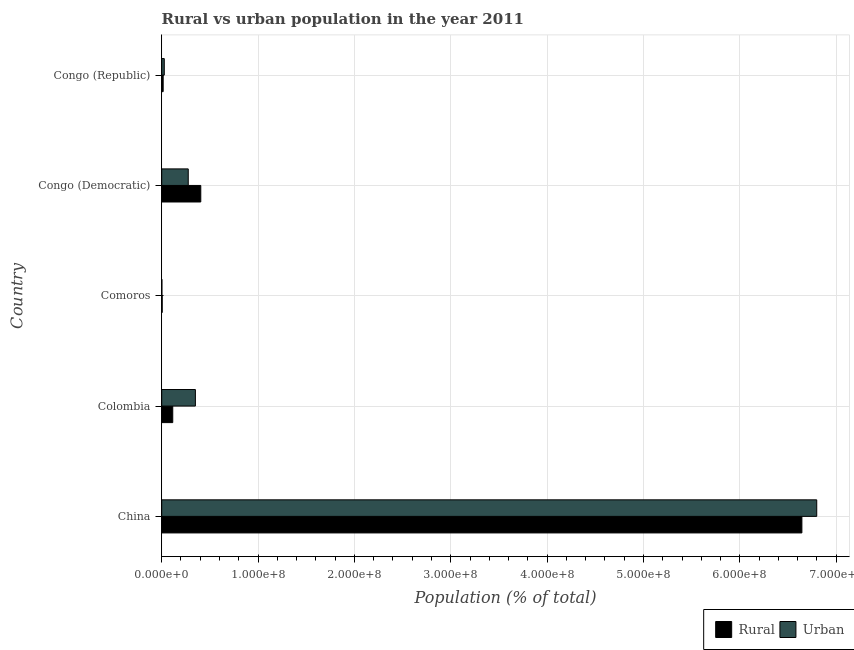How many groups of bars are there?
Keep it short and to the point. 5. Are the number of bars per tick equal to the number of legend labels?
Provide a succinct answer. Yes. What is the label of the 3rd group of bars from the top?
Provide a short and direct response. Comoros. What is the urban population density in Congo (Republic)?
Make the answer very short. 2.66e+06. Across all countries, what is the maximum urban population density?
Offer a terse response. 6.80e+08. Across all countries, what is the minimum rural population density?
Offer a terse response. 5.16e+05. In which country was the urban population density minimum?
Your response must be concise. Comoros. What is the total rural population density in the graph?
Make the answer very short. 7.18e+08. What is the difference between the urban population density in Colombia and that in Congo (Democratic)?
Ensure brevity in your answer.  7.42e+06. What is the difference between the urban population density in Colombia and the rural population density in Congo (Republic)?
Ensure brevity in your answer.  3.34e+07. What is the average urban population density per country?
Keep it short and to the point. 1.49e+08. What is the difference between the rural population density and urban population density in Congo (Republic)?
Ensure brevity in your answer.  -1.14e+06. In how many countries, is the urban population density greater than 220000000 %?
Give a very brief answer. 1. What is the ratio of the rural population density in China to that in Colombia?
Offer a very short reply. 58.01. Is the urban population density in Colombia less than that in Congo (Democratic)?
Offer a terse response. No. Is the difference between the urban population density in China and Congo (Democratic) greater than the difference between the rural population density in China and Congo (Democratic)?
Your response must be concise. Yes. What is the difference between the highest and the second highest urban population density?
Ensure brevity in your answer.  6.45e+08. What is the difference between the highest and the lowest rural population density?
Make the answer very short. 6.64e+08. In how many countries, is the rural population density greater than the average rural population density taken over all countries?
Your response must be concise. 1. What does the 2nd bar from the top in China represents?
Your answer should be very brief. Rural. What does the 1st bar from the bottom in Comoros represents?
Offer a very short reply. Rural. Are all the bars in the graph horizontal?
Your response must be concise. Yes. What is the difference between two consecutive major ticks on the X-axis?
Your answer should be very brief. 1.00e+08. Does the graph contain any zero values?
Your answer should be compact. No. Where does the legend appear in the graph?
Your answer should be very brief. Bottom right. What is the title of the graph?
Your answer should be compact. Rural vs urban population in the year 2011. Does "Diesel" appear as one of the legend labels in the graph?
Offer a very short reply. No. What is the label or title of the X-axis?
Offer a very short reply. Population (% of total). What is the Population (% of total) in Rural in China?
Make the answer very short. 6.64e+08. What is the Population (% of total) in Urban in China?
Your answer should be compact. 6.80e+08. What is the Population (% of total) of Rural in Colombia?
Make the answer very short. 1.15e+07. What is the Population (% of total) in Urban in Colombia?
Your response must be concise. 3.50e+07. What is the Population (% of total) of Rural in Comoros?
Provide a short and direct response. 5.16e+05. What is the Population (% of total) of Urban in Comoros?
Provide a succinct answer. 2.00e+05. What is the Population (% of total) in Rural in Congo (Democratic)?
Keep it short and to the point. 4.06e+07. What is the Population (% of total) in Urban in Congo (Democratic)?
Offer a very short reply. 2.75e+07. What is the Population (% of total) of Rural in Congo (Republic)?
Your response must be concise. 1.52e+06. What is the Population (% of total) in Urban in Congo (Republic)?
Your answer should be very brief. 2.66e+06. Across all countries, what is the maximum Population (% of total) of Rural?
Your response must be concise. 6.64e+08. Across all countries, what is the maximum Population (% of total) of Urban?
Your answer should be compact. 6.80e+08. Across all countries, what is the minimum Population (% of total) of Rural?
Keep it short and to the point. 5.16e+05. Across all countries, what is the minimum Population (% of total) in Urban?
Offer a terse response. 2.00e+05. What is the total Population (% of total) in Rural in the graph?
Make the answer very short. 7.18e+08. What is the total Population (% of total) of Urban in the graph?
Ensure brevity in your answer.  7.45e+08. What is the difference between the Population (% of total) in Rural in China and that in Colombia?
Your answer should be compact. 6.53e+08. What is the difference between the Population (% of total) in Urban in China and that in Colombia?
Ensure brevity in your answer.  6.45e+08. What is the difference between the Population (% of total) of Rural in China and that in Comoros?
Provide a short and direct response. 6.64e+08. What is the difference between the Population (% of total) of Urban in China and that in Comoros?
Offer a very short reply. 6.80e+08. What is the difference between the Population (% of total) of Rural in China and that in Congo (Democratic)?
Your answer should be very brief. 6.24e+08. What is the difference between the Population (% of total) in Urban in China and that in Congo (Democratic)?
Your answer should be compact. 6.52e+08. What is the difference between the Population (% of total) in Rural in China and that in Congo (Republic)?
Provide a short and direct response. 6.63e+08. What is the difference between the Population (% of total) of Urban in China and that in Congo (Republic)?
Offer a very short reply. 6.77e+08. What is the difference between the Population (% of total) in Rural in Colombia and that in Comoros?
Provide a succinct answer. 1.09e+07. What is the difference between the Population (% of total) in Urban in Colombia and that in Comoros?
Offer a terse response. 3.48e+07. What is the difference between the Population (% of total) of Rural in Colombia and that in Congo (Democratic)?
Provide a short and direct response. -2.91e+07. What is the difference between the Population (% of total) in Urban in Colombia and that in Congo (Democratic)?
Provide a succinct answer. 7.42e+06. What is the difference between the Population (% of total) of Rural in Colombia and that in Congo (Republic)?
Your answer should be compact. 9.93e+06. What is the difference between the Population (% of total) of Urban in Colombia and that in Congo (Republic)?
Provide a succinct answer. 3.23e+07. What is the difference between the Population (% of total) of Rural in Comoros and that in Congo (Democratic)?
Keep it short and to the point. -4.00e+07. What is the difference between the Population (% of total) in Urban in Comoros and that in Congo (Democratic)?
Provide a succinct answer. -2.73e+07. What is the difference between the Population (% of total) in Rural in Comoros and that in Congo (Republic)?
Give a very brief answer. -1.00e+06. What is the difference between the Population (% of total) of Urban in Comoros and that in Congo (Republic)?
Give a very brief answer. -2.46e+06. What is the difference between the Population (% of total) of Rural in Congo (Democratic) and that in Congo (Republic)?
Provide a succinct answer. 3.90e+07. What is the difference between the Population (% of total) in Urban in Congo (Democratic) and that in Congo (Republic)?
Give a very brief answer. 2.49e+07. What is the difference between the Population (% of total) in Rural in China and the Population (% of total) in Urban in Colombia?
Offer a very short reply. 6.29e+08. What is the difference between the Population (% of total) of Rural in China and the Population (% of total) of Urban in Comoros?
Offer a terse response. 6.64e+08. What is the difference between the Population (% of total) of Rural in China and the Population (% of total) of Urban in Congo (Democratic)?
Keep it short and to the point. 6.37e+08. What is the difference between the Population (% of total) in Rural in China and the Population (% of total) in Urban in Congo (Republic)?
Ensure brevity in your answer.  6.62e+08. What is the difference between the Population (% of total) of Rural in Colombia and the Population (% of total) of Urban in Comoros?
Your answer should be very brief. 1.13e+07. What is the difference between the Population (% of total) of Rural in Colombia and the Population (% of total) of Urban in Congo (Democratic)?
Your response must be concise. -1.61e+07. What is the difference between the Population (% of total) of Rural in Colombia and the Population (% of total) of Urban in Congo (Republic)?
Make the answer very short. 8.79e+06. What is the difference between the Population (% of total) in Rural in Comoros and the Population (% of total) in Urban in Congo (Democratic)?
Offer a very short reply. -2.70e+07. What is the difference between the Population (% of total) of Rural in Comoros and the Population (% of total) of Urban in Congo (Republic)?
Make the answer very short. -2.14e+06. What is the difference between the Population (% of total) in Rural in Congo (Democratic) and the Population (% of total) in Urban in Congo (Republic)?
Offer a very short reply. 3.79e+07. What is the average Population (% of total) in Rural per country?
Ensure brevity in your answer.  1.44e+08. What is the average Population (% of total) in Urban per country?
Offer a terse response. 1.49e+08. What is the difference between the Population (% of total) of Rural and Population (% of total) of Urban in China?
Make the answer very short. -1.54e+07. What is the difference between the Population (% of total) in Rural and Population (% of total) in Urban in Colombia?
Your answer should be very brief. -2.35e+07. What is the difference between the Population (% of total) of Rural and Population (% of total) of Urban in Comoros?
Keep it short and to the point. 3.16e+05. What is the difference between the Population (% of total) of Rural and Population (% of total) of Urban in Congo (Democratic)?
Provide a short and direct response. 1.30e+07. What is the difference between the Population (% of total) of Rural and Population (% of total) of Urban in Congo (Republic)?
Keep it short and to the point. -1.14e+06. What is the ratio of the Population (% of total) of Rural in China to that in Colombia?
Make the answer very short. 58.01. What is the ratio of the Population (% of total) in Urban in China to that in Colombia?
Provide a succinct answer. 19.45. What is the ratio of the Population (% of total) in Rural in China to that in Comoros?
Provide a succinct answer. 1288.17. What is the ratio of the Population (% of total) in Urban in China to that in Comoros?
Give a very brief answer. 3394.95. What is the ratio of the Population (% of total) of Rural in China to that in Congo (Democratic)?
Your answer should be very brief. 16.38. What is the ratio of the Population (% of total) of Urban in China to that in Congo (Democratic)?
Give a very brief answer. 24.69. What is the ratio of the Population (% of total) of Rural in China to that in Congo (Republic)?
Keep it short and to the point. 437.71. What is the ratio of the Population (% of total) in Urban in China to that in Congo (Republic)?
Your response must be concise. 255.59. What is the ratio of the Population (% of total) in Rural in Colombia to that in Comoros?
Make the answer very short. 22.21. What is the ratio of the Population (% of total) in Urban in Colombia to that in Comoros?
Offer a very short reply. 174.57. What is the ratio of the Population (% of total) of Rural in Colombia to that in Congo (Democratic)?
Keep it short and to the point. 0.28. What is the ratio of the Population (% of total) in Urban in Colombia to that in Congo (Democratic)?
Provide a succinct answer. 1.27. What is the ratio of the Population (% of total) of Rural in Colombia to that in Congo (Republic)?
Provide a short and direct response. 7.55. What is the ratio of the Population (% of total) in Urban in Colombia to that in Congo (Republic)?
Keep it short and to the point. 13.14. What is the ratio of the Population (% of total) of Rural in Comoros to that in Congo (Democratic)?
Provide a succinct answer. 0.01. What is the ratio of the Population (% of total) in Urban in Comoros to that in Congo (Democratic)?
Make the answer very short. 0.01. What is the ratio of the Population (% of total) in Rural in Comoros to that in Congo (Republic)?
Your answer should be compact. 0.34. What is the ratio of the Population (% of total) of Urban in Comoros to that in Congo (Republic)?
Offer a very short reply. 0.08. What is the ratio of the Population (% of total) of Rural in Congo (Democratic) to that in Congo (Republic)?
Your answer should be very brief. 26.72. What is the ratio of the Population (% of total) in Urban in Congo (Democratic) to that in Congo (Republic)?
Your answer should be compact. 10.35. What is the difference between the highest and the second highest Population (% of total) in Rural?
Make the answer very short. 6.24e+08. What is the difference between the highest and the second highest Population (% of total) of Urban?
Keep it short and to the point. 6.45e+08. What is the difference between the highest and the lowest Population (% of total) of Rural?
Make the answer very short. 6.64e+08. What is the difference between the highest and the lowest Population (% of total) in Urban?
Your answer should be compact. 6.80e+08. 